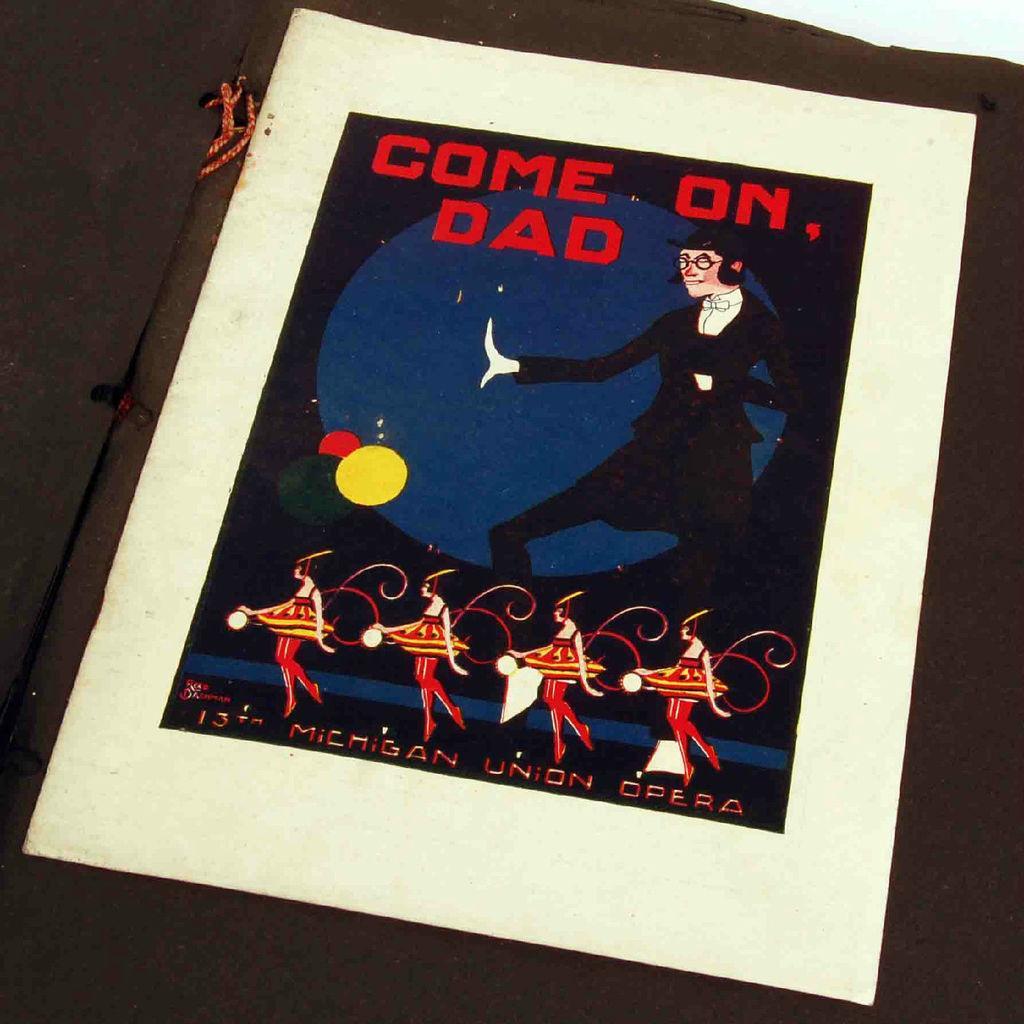Please provide a concise description of this image. In this picture we can see a poster with the name of come on dad. Here we can see a person who is doing some activity and he wore spectacles. Here four persons are in motion of dance. 